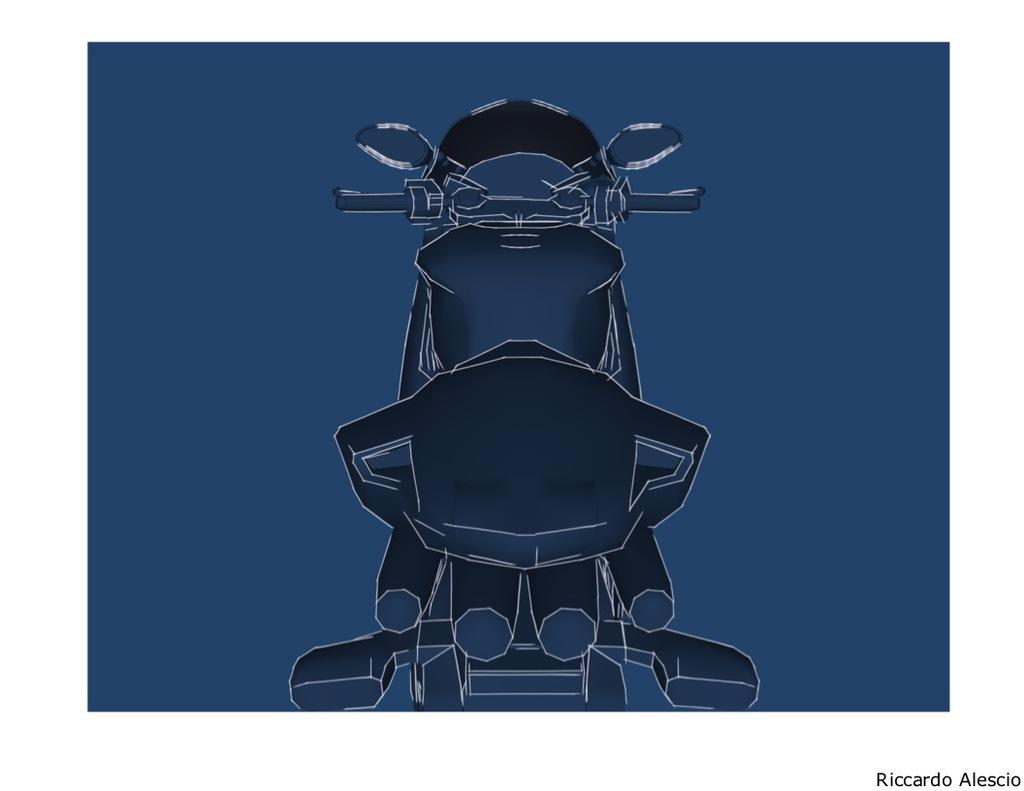What is the main subject of the image? The main subject of the image is a drawing of a cartoon. How many cherries are present in the image? There is no mention of cherries in the image, as the only fact provided is that there is a drawing of a cartoon. 